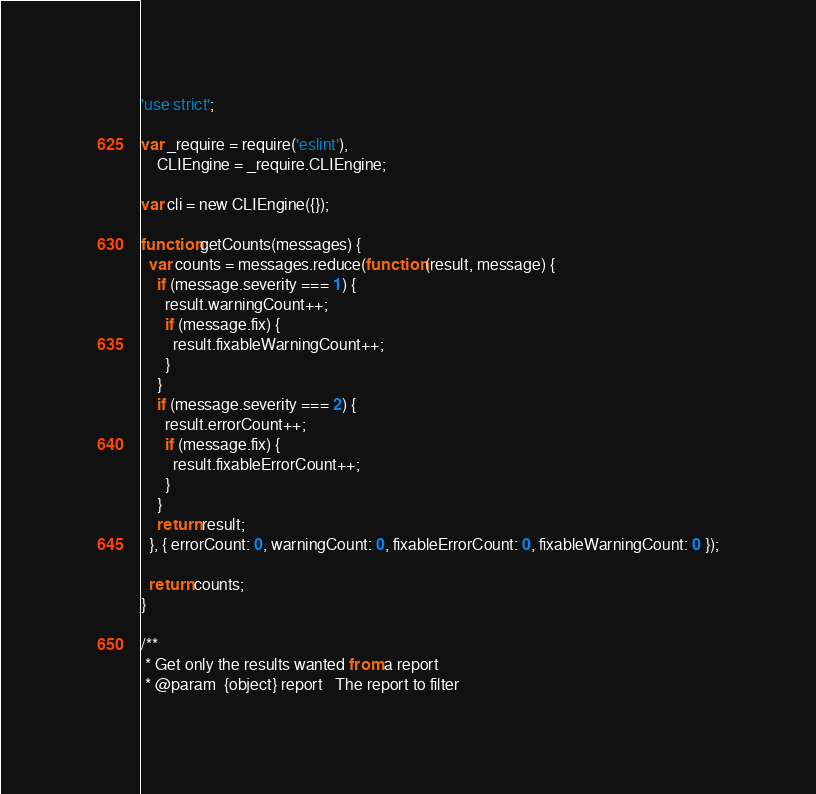<code> <loc_0><loc_0><loc_500><loc_500><_JavaScript_>'use strict';

var _require = require('eslint'),
    CLIEngine = _require.CLIEngine;

var cli = new CLIEngine({});

function getCounts(messages) {
  var counts = messages.reduce(function (result, message) {
    if (message.severity === 1) {
      result.warningCount++;
      if (message.fix) {
        result.fixableWarningCount++;
      }
    }
    if (message.severity === 2) {
      result.errorCount++;
      if (message.fix) {
        result.fixableErrorCount++;
      }
    }
    return result;
  }, { errorCount: 0, warningCount: 0, fixableErrorCount: 0, fixableWarningCount: 0 });

  return counts;
}

/**
 * Get only the results wanted from a report
 * @param  {object} report   The report to filter</code> 